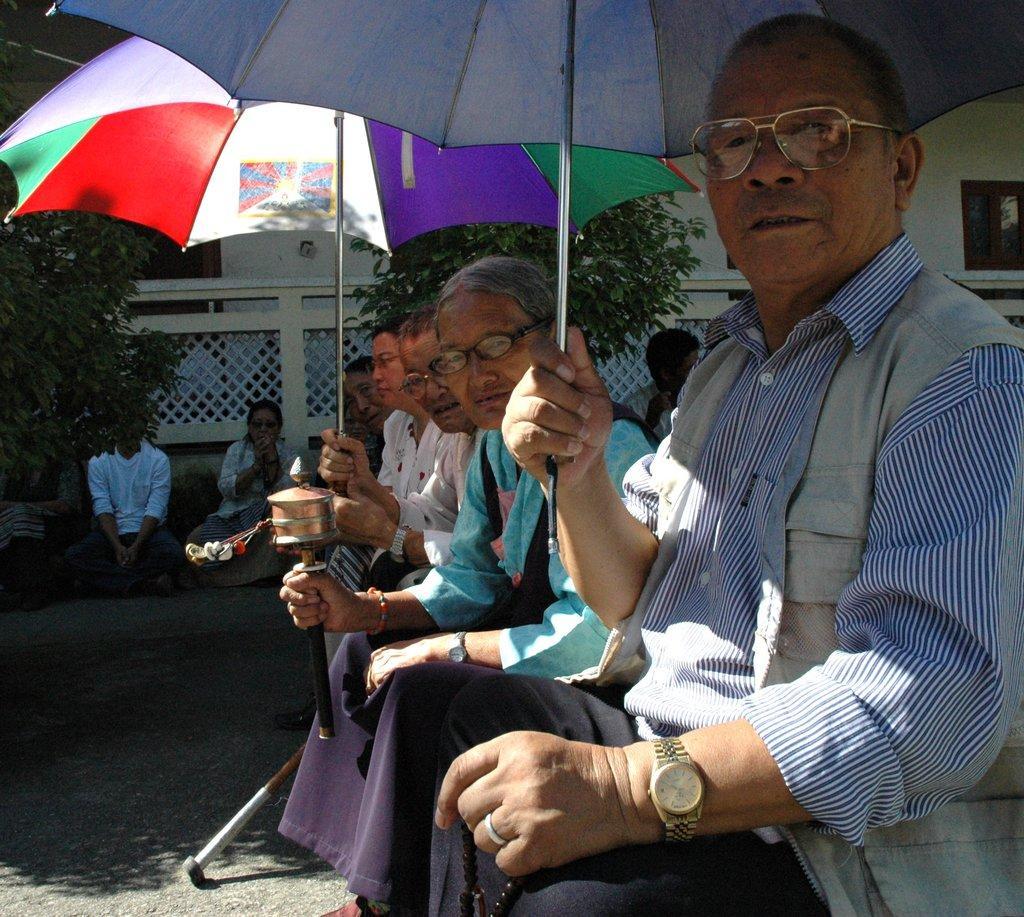Could you give a brief overview of what you see in this image? In this image we can see some group of old men sitting, some are wearing spectacles and some are holding umbrellas in their hands and in the background of the image there are some plants, fencing and there is a wall. 